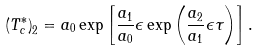Convert formula to latex. <formula><loc_0><loc_0><loc_500><loc_500>\left ( T _ { c } ^ { * } \right ) _ { 2 } = a _ { 0 } \exp \left [ \frac { a _ { 1 } } { a _ { 0 } } \epsilon \exp \left ( \frac { a _ { 2 } } { a _ { 1 } } \epsilon \tau \right ) \right ] .</formula> 